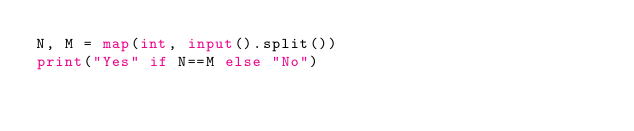<code> <loc_0><loc_0><loc_500><loc_500><_Python_>N, M = map(int, input().split())
print("Yes" if N==M else "No")</code> 